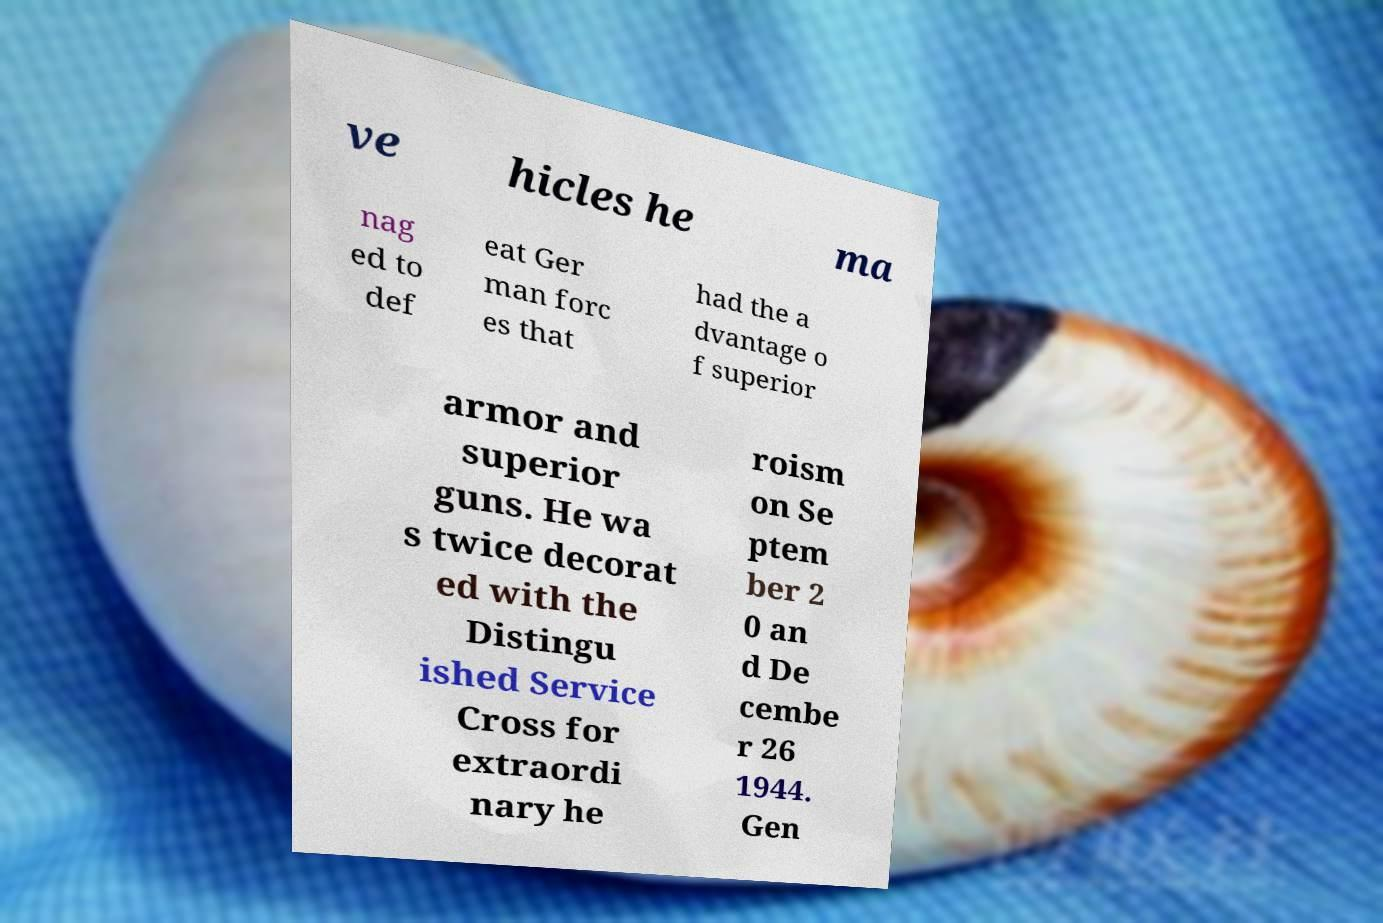I need the written content from this picture converted into text. Can you do that? ve hicles he ma nag ed to def eat Ger man forc es that had the a dvantage o f superior armor and superior guns. He wa s twice decorat ed with the Distingu ished Service Cross for extraordi nary he roism on Se ptem ber 2 0 an d De cembe r 26 1944. Gen 